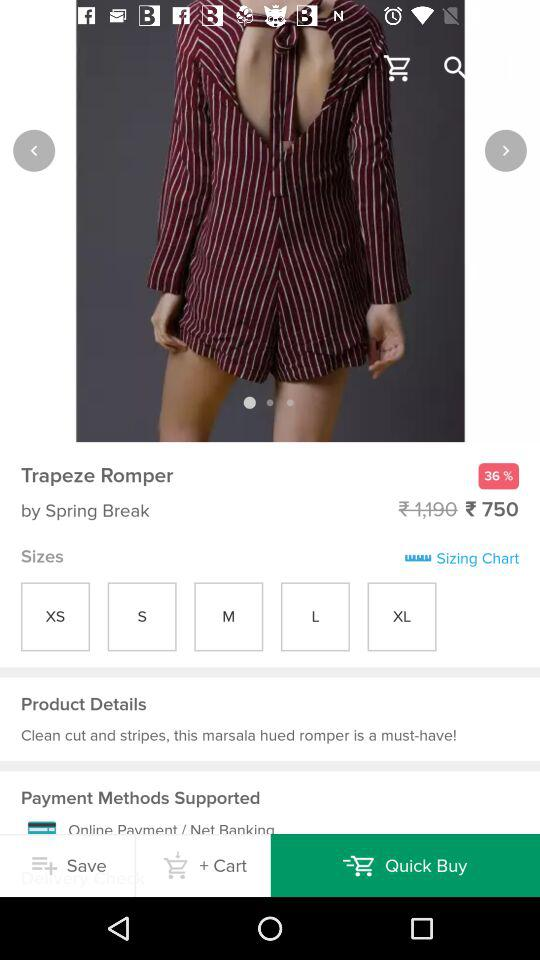How much is a discount on the "Trapeze Romper"? The discount is 36%. 